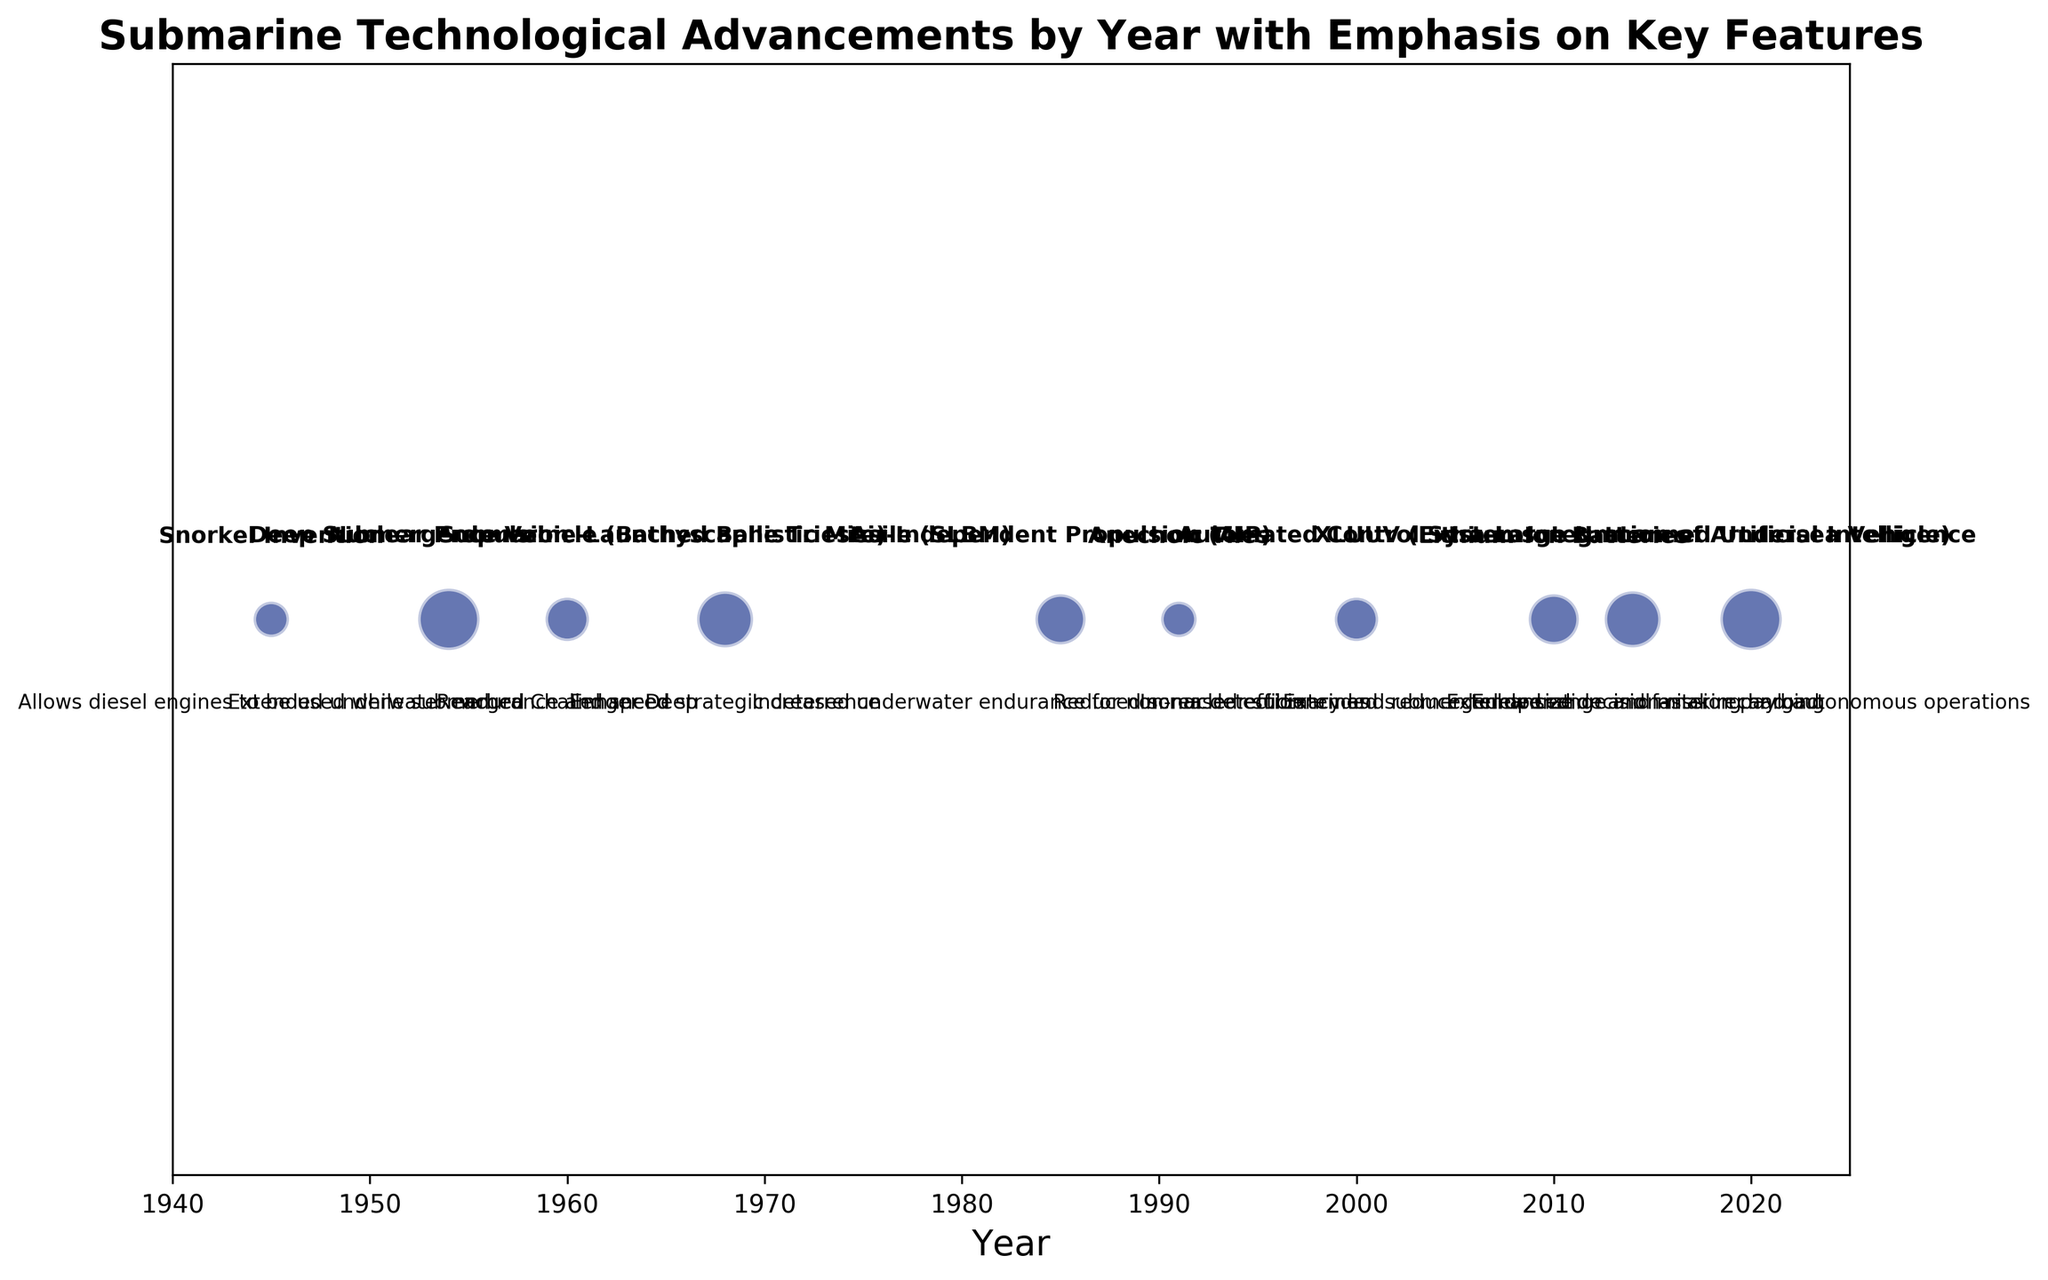What is the bubble size for the Nuclear Propulsion advancement? Look for the bubble labeled "Nuclear Propulsion" and note its size. The figure shows that Nuclear Propulsion has a bubble of size 30.
Answer: 30 Which advancement occurred in 2014 and what key feature does it emphasize? Find the bubble for the year 2014, which is labeled as XLUUV (Extra-Large Unmanned Undersea Vehicle). The key feature mentioned is "Extended range and mission payload".
Answer: XLUUV (Extra-Large Unmanned Undersea Vehicle), Extended range and mission payload Arrange the advancements in order of their bubble sizes from smallest to largest. Observe and compare the sizes of each bubble and arrange them in ascending order: Snorkel Invention (10), Anechoic Tiles (10), Deep Submergence Vehicle (Bathyscaphe Trieste) (15), Automated Control Systems (15), Air-Independent Propulsion (AIP) (20), Lithium-Ion Batteries (20), Submarine-Launched Ballistic Missile (SLBM) (25), XLUUV (Extra-Large Unmanned Undersea Vehicle) (25), Nuclear Propulsion (30), Integration of Artificial Intelligence (30).
Answer: Snorkel Invention, Anechoic Tiles, Deep Submergence Vehicle (Bathyscaphe Trieste), Automated Control Systems, Air-Independent Propulsion (AIP), Lithium-Ion Batteries, Submarine-Launched Ballistic Missile (SLBM), XLUUV (Extra-Large Unmanned Undersea Vehicle), Nuclear Propulsion, Integration of Artificial Intelligence Which two advancements have the largest bubble sizes and what years do they correspond to? Identify the advancements with the largest bubble sizes. The figure shows that Nuclear Propulsion and Integration of Artificial Intelligence both have the largest bubbles of size 30, corresponding to the years 1954 and 2020 respectively.
Answer: Nuclear Propulsion (1954) and Integration of Artificial Intelligence (2020) What is the difference in years between the advancements of Automated Control Systems and Deep Submergence Vehicle (Bathyscaphe Trieste)? Locate the years of Automated Control Systems (2000) and Deep Submergence Vehicle (Bathyscaphe Trieste) (1960). Subtract the earlier year from the later year: 2000 - 1960 = 40.
Answer: 40 years 